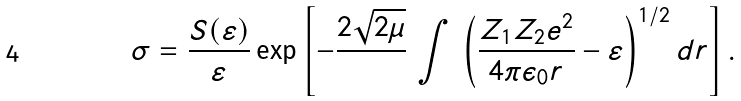<formula> <loc_0><loc_0><loc_500><loc_500>\sigma = { \frac { S ( \varepsilon ) } { \varepsilon } } \exp \left [ - \frac { 2 \sqrt { 2 \mu } } { } \, \int \, \left ( \frac { Z _ { 1 } Z _ { 2 } e ^ { 2 } } { 4 \pi \epsilon _ { 0 } r } - \varepsilon \right ) ^ { 1 / 2 } d r \right ] .</formula> 